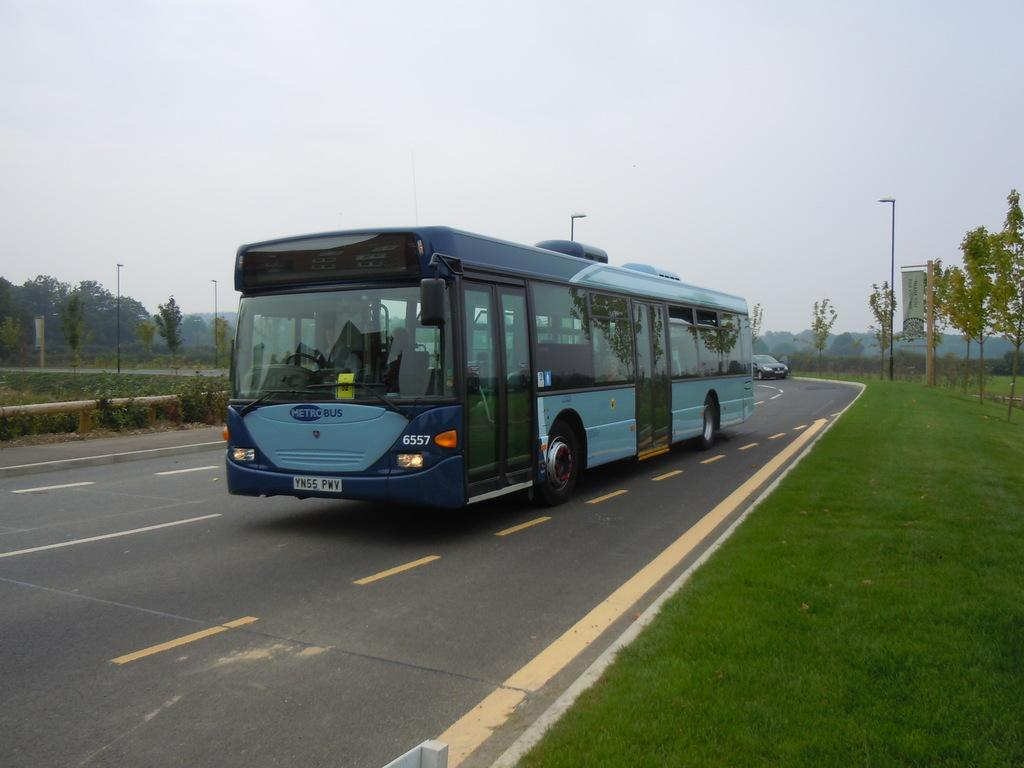What type of vehicle is in the image? There is a bus and a car in the image. Where are the vehicles located? Both the bus and car are on the road. Are there any passengers in the vehicles? Yes, there are people seated in the bus. What can be seen in the background of the image? There is grass, poles, trees, and hoardings visible in the background. What type of sponge is being used to clean the car in the image? There is no sponge present in the image, and the car is not being cleaned. What reward is being given to the passengers on the bus in the image? There is no reward being given to the passengers in the image. 